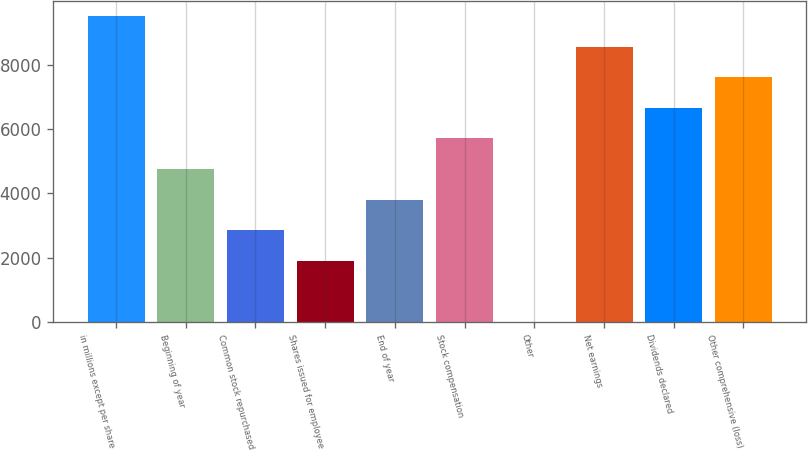<chart> <loc_0><loc_0><loc_500><loc_500><bar_chart><fcel>in millions except per share<fcel>Beginning of year<fcel>Common stock repurchased<fcel>Shares issued for employee<fcel>End of year<fcel>Stock compensation<fcel>Other<fcel>Net earnings<fcel>Dividends declared<fcel>Other comprehensive (loss)<nl><fcel>9514<fcel>4758<fcel>2855.6<fcel>1904.4<fcel>3806.8<fcel>5709.2<fcel>2<fcel>8562.8<fcel>6660.4<fcel>7611.6<nl></chart> 